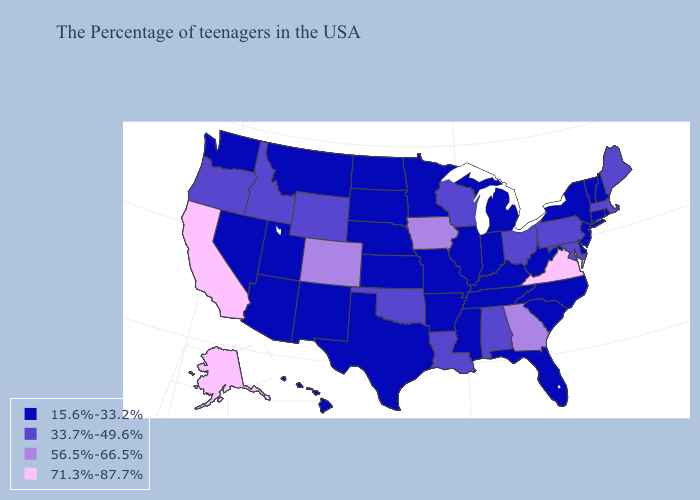Name the states that have a value in the range 15.6%-33.2%?
Keep it brief. Rhode Island, New Hampshire, Vermont, Connecticut, New York, New Jersey, Delaware, North Carolina, South Carolina, West Virginia, Florida, Michigan, Kentucky, Indiana, Tennessee, Illinois, Mississippi, Missouri, Arkansas, Minnesota, Kansas, Nebraska, Texas, South Dakota, North Dakota, New Mexico, Utah, Montana, Arizona, Nevada, Washington, Hawaii. What is the lowest value in the South?
Short answer required. 15.6%-33.2%. What is the highest value in states that border Tennessee?
Keep it brief. 71.3%-87.7%. Which states have the highest value in the USA?
Keep it brief. Virginia, California, Alaska. Name the states that have a value in the range 33.7%-49.6%?
Answer briefly. Maine, Massachusetts, Maryland, Pennsylvania, Ohio, Alabama, Wisconsin, Louisiana, Oklahoma, Wyoming, Idaho, Oregon. Which states have the lowest value in the USA?
Short answer required. Rhode Island, New Hampshire, Vermont, Connecticut, New York, New Jersey, Delaware, North Carolina, South Carolina, West Virginia, Florida, Michigan, Kentucky, Indiana, Tennessee, Illinois, Mississippi, Missouri, Arkansas, Minnesota, Kansas, Nebraska, Texas, South Dakota, North Dakota, New Mexico, Utah, Montana, Arizona, Nevada, Washington, Hawaii. Does California have the same value as Alabama?
Keep it brief. No. Which states hav the highest value in the South?
Write a very short answer. Virginia. What is the highest value in the MidWest ?
Short answer required. 56.5%-66.5%. What is the value of Arizona?
Short answer required. 15.6%-33.2%. Name the states that have a value in the range 56.5%-66.5%?
Write a very short answer. Georgia, Iowa, Colorado. Name the states that have a value in the range 33.7%-49.6%?
Write a very short answer. Maine, Massachusetts, Maryland, Pennsylvania, Ohio, Alabama, Wisconsin, Louisiana, Oklahoma, Wyoming, Idaho, Oregon. Does Massachusetts have the same value as Indiana?
Give a very brief answer. No. Name the states that have a value in the range 33.7%-49.6%?
Be succinct. Maine, Massachusetts, Maryland, Pennsylvania, Ohio, Alabama, Wisconsin, Louisiana, Oklahoma, Wyoming, Idaho, Oregon. Among the states that border Florida , which have the lowest value?
Give a very brief answer. Alabama. 